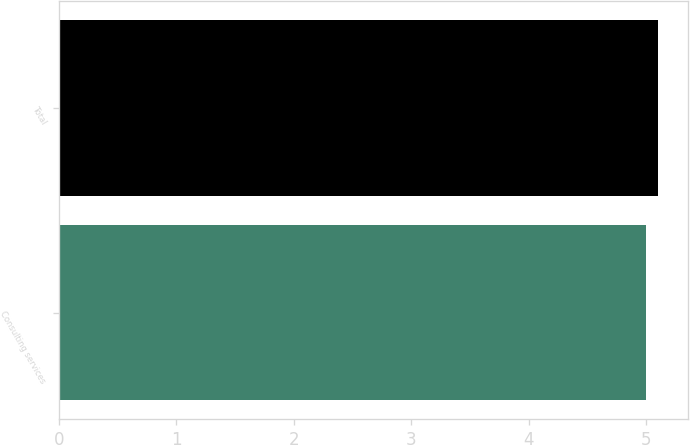Convert chart. <chart><loc_0><loc_0><loc_500><loc_500><bar_chart><fcel>Consulting services<fcel>Total<nl><fcel>5<fcel>5.1<nl></chart> 